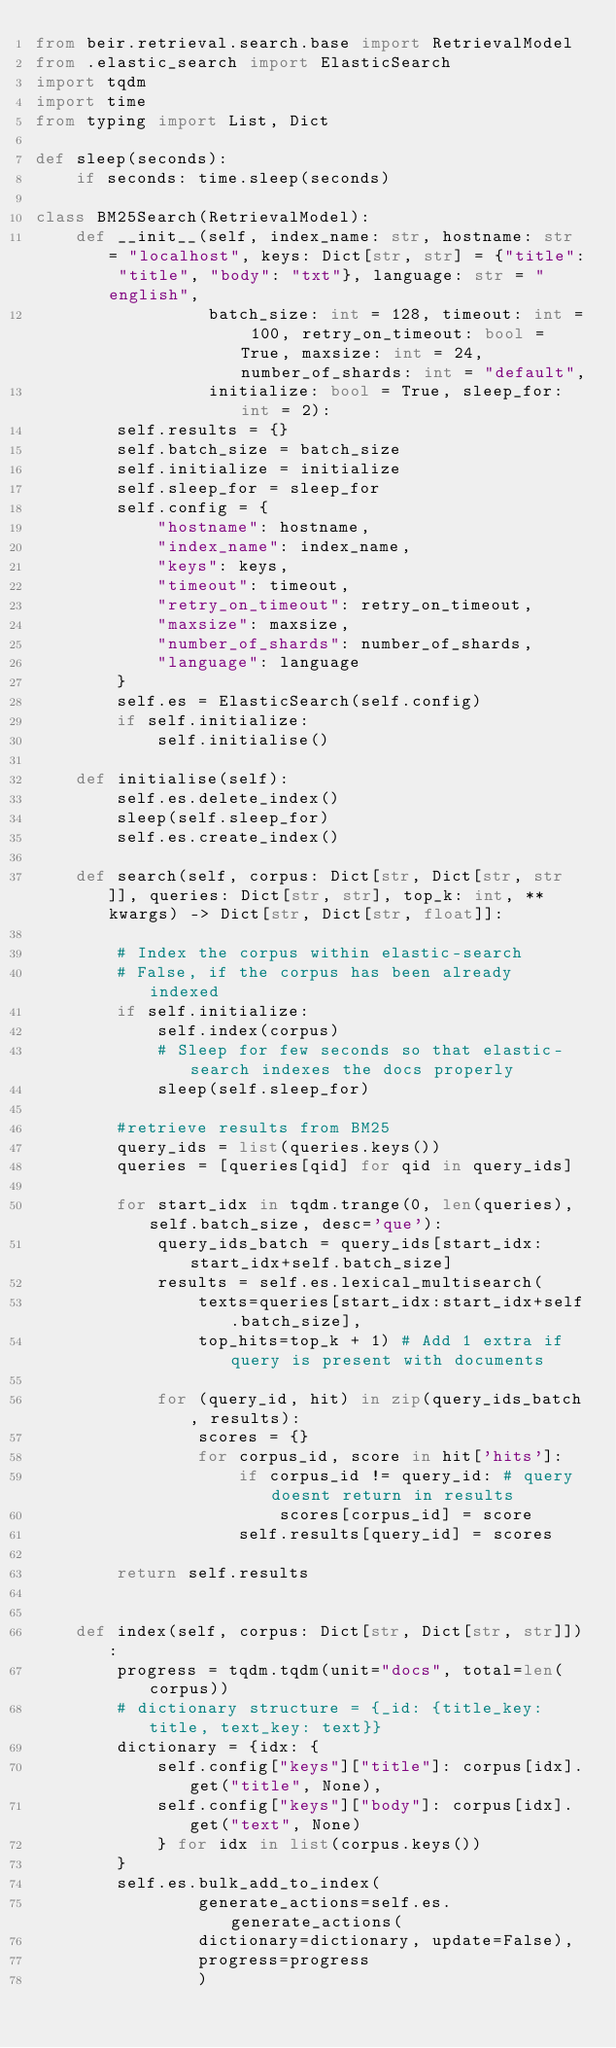<code> <loc_0><loc_0><loc_500><loc_500><_Python_>from beir.retrieval.search.base import RetrievalModel
from .elastic_search import ElasticSearch
import tqdm
import time
from typing import List, Dict

def sleep(seconds):
    if seconds: time.sleep(seconds) 

class BM25Search(RetrievalModel):
    def __init__(self, index_name: str, hostname: str = "localhost", keys: Dict[str, str] = {"title": "title", "body": "txt"}, language: str = "english",
                 batch_size: int = 128, timeout: int = 100, retry_on_timeout: bool = True, maxsize: int = 24, number_of_shards: int = "default", 
                 initialize: bool = True, sleep_for: int = 2):
        self.results = {}
        self.batch_size = batch_size
        self.initialize = initialize
        self.sleep_for = sleep_for
        self.config = {
            "hostname": hostname, 
            "index_name": index_name,
            "keys": keys,
            "timeout": timeout,
            "retry_on_timeout": retry_on_timeout,
            "maxsize": maxsize,
            "number_of_shards": number_of_shards,
            "language": language
        }
        self.es = ElasticSearch(self.config)
        if self.initialize:
            self.initialise()
    
    def initialise(self):
        self.es.delete_index()
        sleep(self.sleep_for)
        self.es.create_index()
    
    def search(self, corpus: Dict[str, Dict[str, str]], queries: Dict[str, str], top_k: int, **kwargs) -> Dict[str, Dict[str, float]]:
        
        # Index the corpus within elastic-search
        # False, if the corpus has been already indexed
        if self.initialize:
            self.index(corpus)
            # Sleep for few seconds so that elastic-search indexes the docs properly
            sleep(self.sleep_for)
        
        #retrieve results from BM25 
        query_ids = list(queries.keys())
        queries = [queries[qid] for qid in query_ids]
        
        for start_idx in tqdm.trange(0, len(queries), self.batch_size, desc='que'):
            query_ids_batch = query_ids[start_idx:start_idx+self.batch_size]
            results = self.es.lexical_multisearch(
                texts=queries[start_idx:start_idx+self.batch_size], 
                top_hits=top_k + 1) # Add 1 extra if query is present with documents
            
            for (query_id, hit) in zip(query_ids_batch, results):
                scores = {}
                for corpus_id, score in hit['hits']:
                    if corpus_id != query_id: # query doesnt return in results
                        scores[corpus_id] = score
                    self.results[query_id] = scores
        
        return self.results
        
    
    def index(self, corpus: Dict[str, Dict[str, str]]):
        progress = tqdm.tqdm(unit="docs", total=len(corpus))
        # dictionary structure = {_id: {title_key: title, text_key: text}}
        dictionary = {idx: {
            self.config["keys"]["title"]: corpus[idx].get("title", None), 
            self.config["keys"]["body"]: corpus[idx].get("text", None)
            } for idx in list(corpus.keys())
        }
        self.es.bulk_add_to_index(
                generate_actions=self.es.generate_actions(
                dictionary=dictionary, update=False),
                progress=progress
                )</code> 